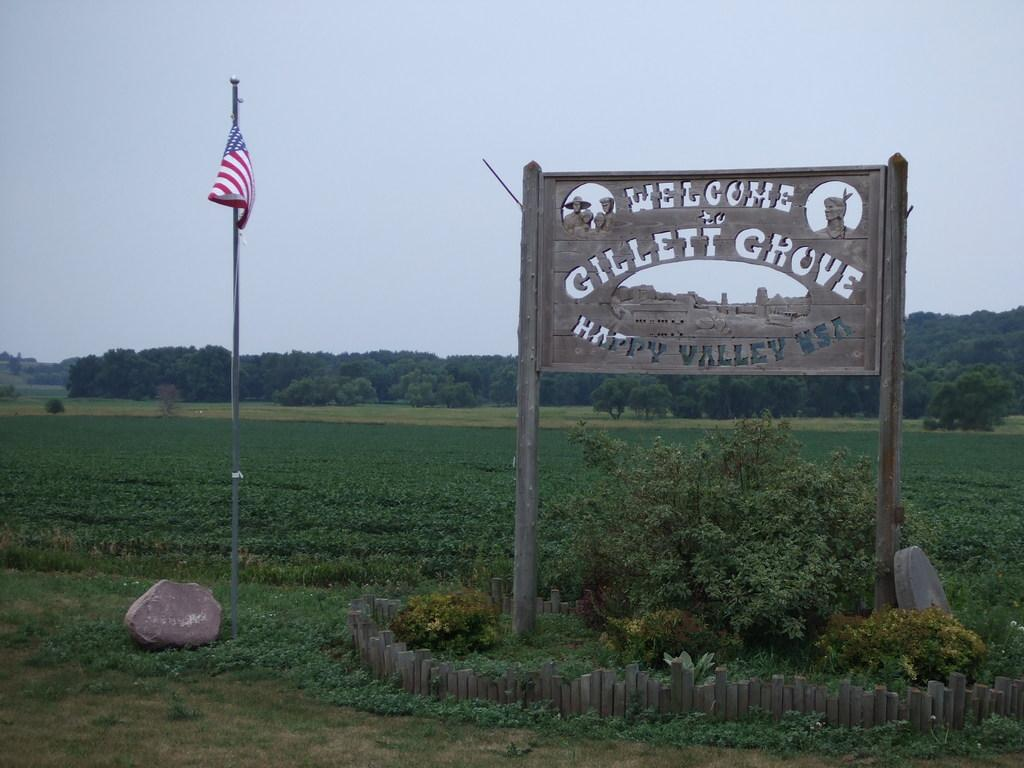What is beside the stone in the image? There is a pole beside the stone in the image. What is attached to the pole? A flag is attached to the pole. What is present between the poles in the image? There is a board between the poles in the image. What type of vegetation can be seen behind the poles? There are trees behind the poles in the image. What is the ground surface like in the image? There is grass visible in the image. Where are the flowers arranged in the image? There are no flowers present in the image. What type of canvas is being used to create the image? The image is not a painting or drawing, so there is no canvas involved in its creation. 